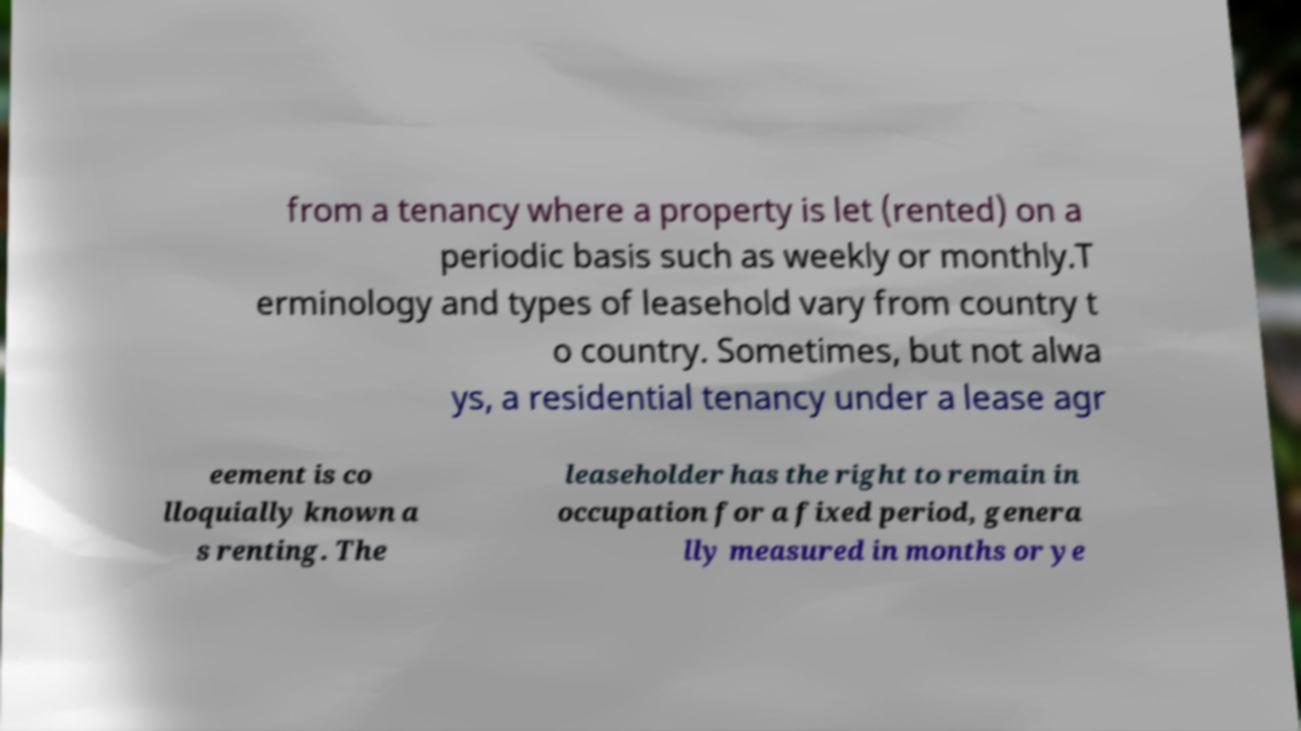Could you assist in decoding the text presented in this image and type it out clearly? from a tenancy where a property is let (rented) on a periodic basis such as weekly or monthly.T erminology and types of leasehold vary from country t o country. Sometimes, but not alwa ys, a residential tenancy under a lease agr eement is co lloquially known a s renting. The leaseholder has the right to remain in occupation for a fixed period, genera lly measured in months or ye 